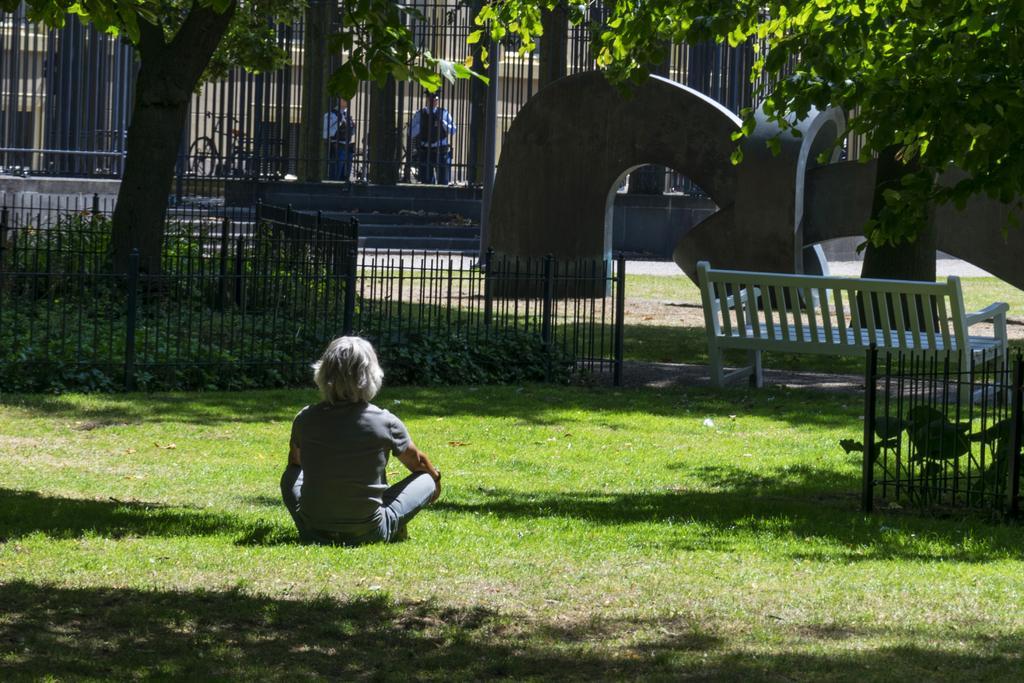Could you give a brief overview of what you see in this image? In this image we can see a person sitting on the grass. We can also see the trees, bench, fence and some plants. We can also see the path, stairs and bicycle and two people in the background. 